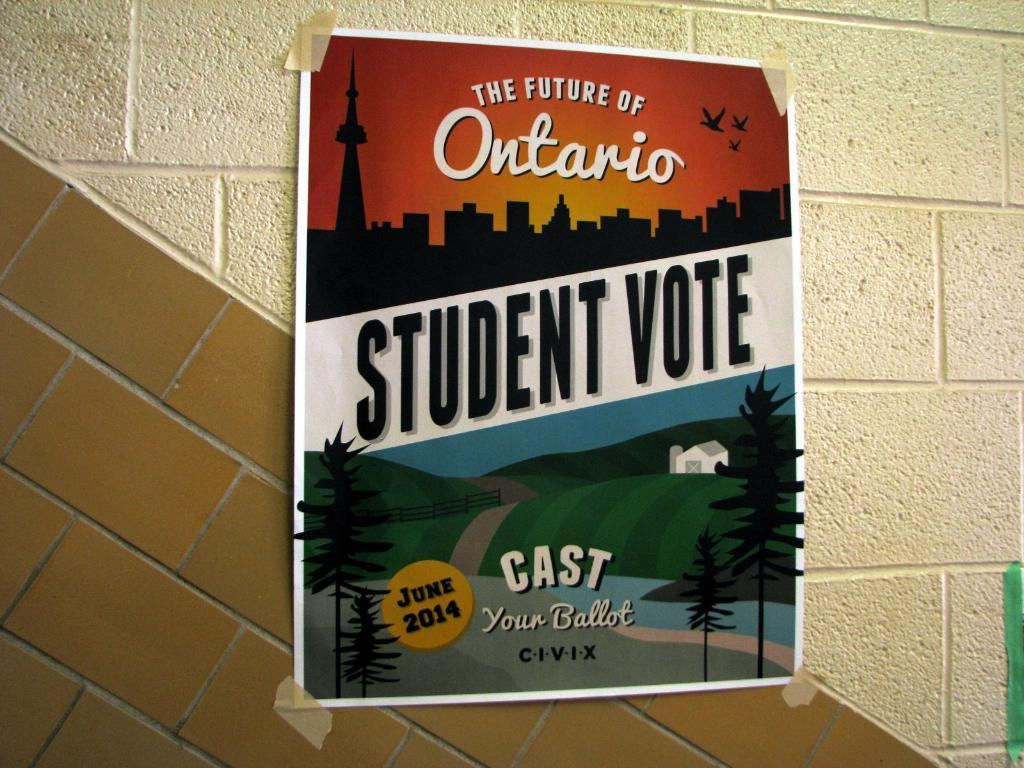Provide a one-sentence caption for the provided image. A flyer encouraging student to vote for the future of Ontario. 